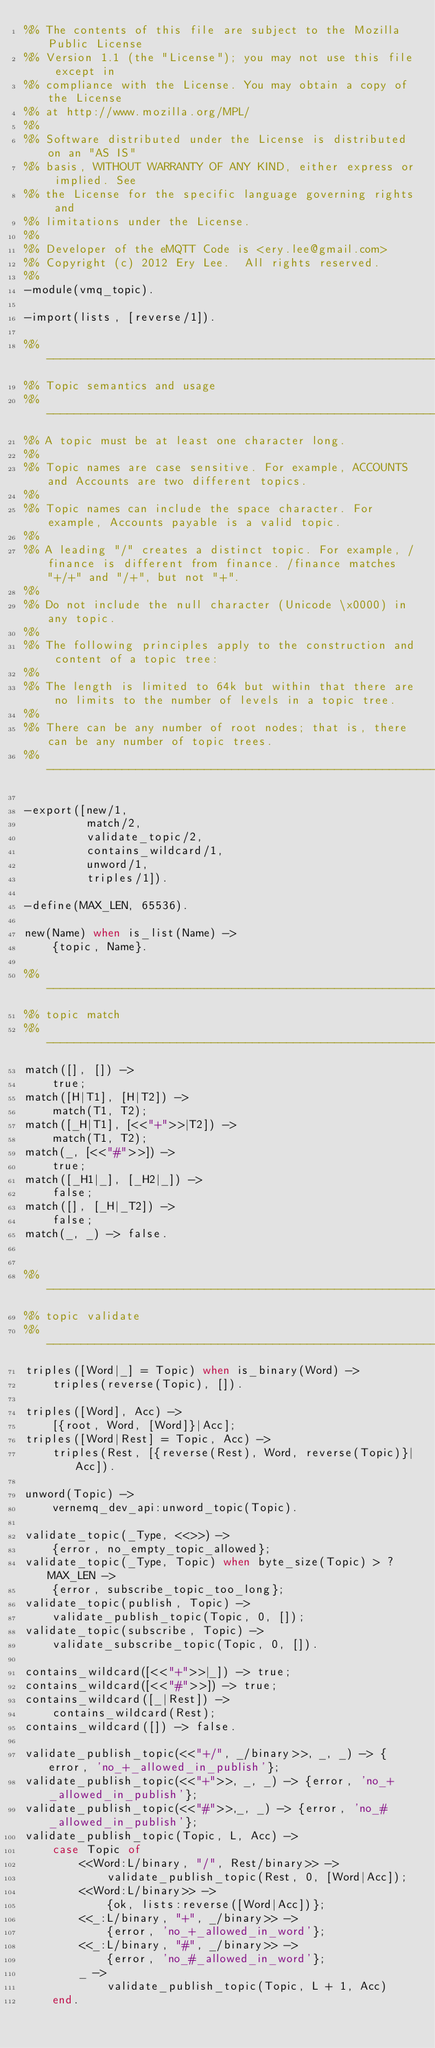Convert code to text. <code><loc_0><loc_0><loc_500><loc_500><_Erlang_>%% The contents of this file are subject to the Mozilla Public License
%% Version 1.1 (the "License"); you may not use this file except in
%% compliance with the License. You may obtain a copy of the License
%% at http://www.mozilla.org/MPL/
%%
%% Software distributed under the License is distributed on an "AS IS"
%% basis, WITHOUT WARRANTY OF ANY KIND, either express or implied. See
%% the License for the specific language governing rights and
%% limitations under the License.
%%
%% Developer of the eMQTT Code is <ery.lee@gmail.com>
%% Copyright (c) 2012 Ery Lee.  All rights reserved.
%%
-module(vmq_topic).

-import(lists, [reverse/1]).

%% ------------------------------------------------------------------------
%% Topic semantics and usage
%% ------------------------------------------------------------------------
%% A topic must be at least one character long.
%%
%% Topic names are case sensitive. For example, ACCOUNTS and Accounts are two different topics.
%%
%% Topic names can include the space character. For example, Accounts payable is a valid topic.
%%
%% A leading "/" creates a distinct topic. For example, /finance is different from finance. /finance matches "+/+" and "/+", but not "+".
%%
%% Do not include the null character (Unicode \x0000) in any topic.
%%
%% The following principles apply to the construction and content of a topic tree:
%%
%% The length is limited to 64k but within that there are no limits to the number of levels in a topic tree.
%%
%% There can be any number of root nodes; that is, there can be any number of topic trees.
%% ------------------------------------------------------------------------

-export([new/1,
         match/2,
         validate_topic/2,
         contains_wildcard/1,
         unword/1,
         triples/1]).

-define(MAX_LEN, 65536).

new(Name) when is_list(Name) ->
    {topic, Name}.

%% ------------------------------------------------------------------------
%% topic match
%% ------------------------------------------------------------------------
match([], []) ->
	true;
match([H|T1], [H|T2]) ->
	match(T1, T2);
match([_H|T1], [<<"+">>|T2]) ->
	match(T1, T2);
match(_, [<<"#">>]) ->
	true;
match([_H1|_], [_H2|_]) ->
	false;
match([], [_H|_T2]) ->
	false;
match(_, _) -> false.


%% ------------------------------------------------------------------------
%% topic validate
%% ------------------------------------------------------------------------
triples([Word|_] = Topic) when is_binary(Word) ->
    triples(reverse(Topic), []).

triples([Word], Acc) ->
    [{root, Word, [Word]}|Acc];
triples([Word|Rest] = Topic, Acc) ->
    triples(Rest, [{reverse(Rest), Word, reverse(Topic)}|Acc]).

unword(Topic) ->
    vernemq_dev_api:unword_topic(Topic).

validate_topic(_Type, <<>>) ->
    {error, no_empty_topic_allowed};
validate_topic(_Type, Topic) when byte_size(Topic) > ?MAX_LEN ->
    {error, subscribe_topic_too_long};
validate_topic(publish, Topic) ->
    validate_publish_topic(Topic, 0, []);
validate_topic(subscribe, Topic) ->
    validate_subscribe_topic(Topic, 0, []).

contains_wildcard([<<"+">>|_]) -> true;
contains_wildcard([<<"#">>]) -> true;
contains_wildcard([_|Rest]) ->
    contains_wildcard(Rest);
contains_wildcard([]) -> false.

validate_publish_topic(<<"+/", _/binary>>, _, _) -> {error, 'no_+_allowed_in_publish'};
validate_publish_topic(<<"+">>, _, _) -> {error, 'no_+_allowed_in_publish'};
validate_publish_topic(<<"#">>,_, _) -> {error, 'no_#_allowed_in_publish'};
validate_publish_topic(Topic, L, Acc) ->
    case Topic of
        <<Word:L/binary, "/", Rest/binary>> ->
            validate_publish_topic(Rest, 0, [Word|Acc]);
        <<Word:L/binary>> ->
            {ok, lists:reverse([Word|Acc])};
        <<_:L/binary, "+", _/binary>> ->
            {error, 'no_+_allowed_in_word'};
        <<_:L/binary, "#", _/binary>> ->
            {error, 'no_#_allowed_in_word'};
        _ ->
            validate_publish_topic(Topic, L + 1, Acc)
    end.
</code> 